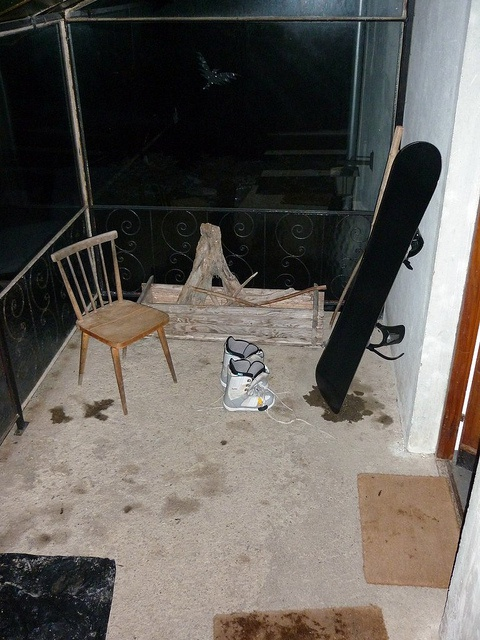Describe the objects in this image and their specific colors. I can see snowboard in black, gray, and darkgray tones and chair in black and gray tones in this image. 